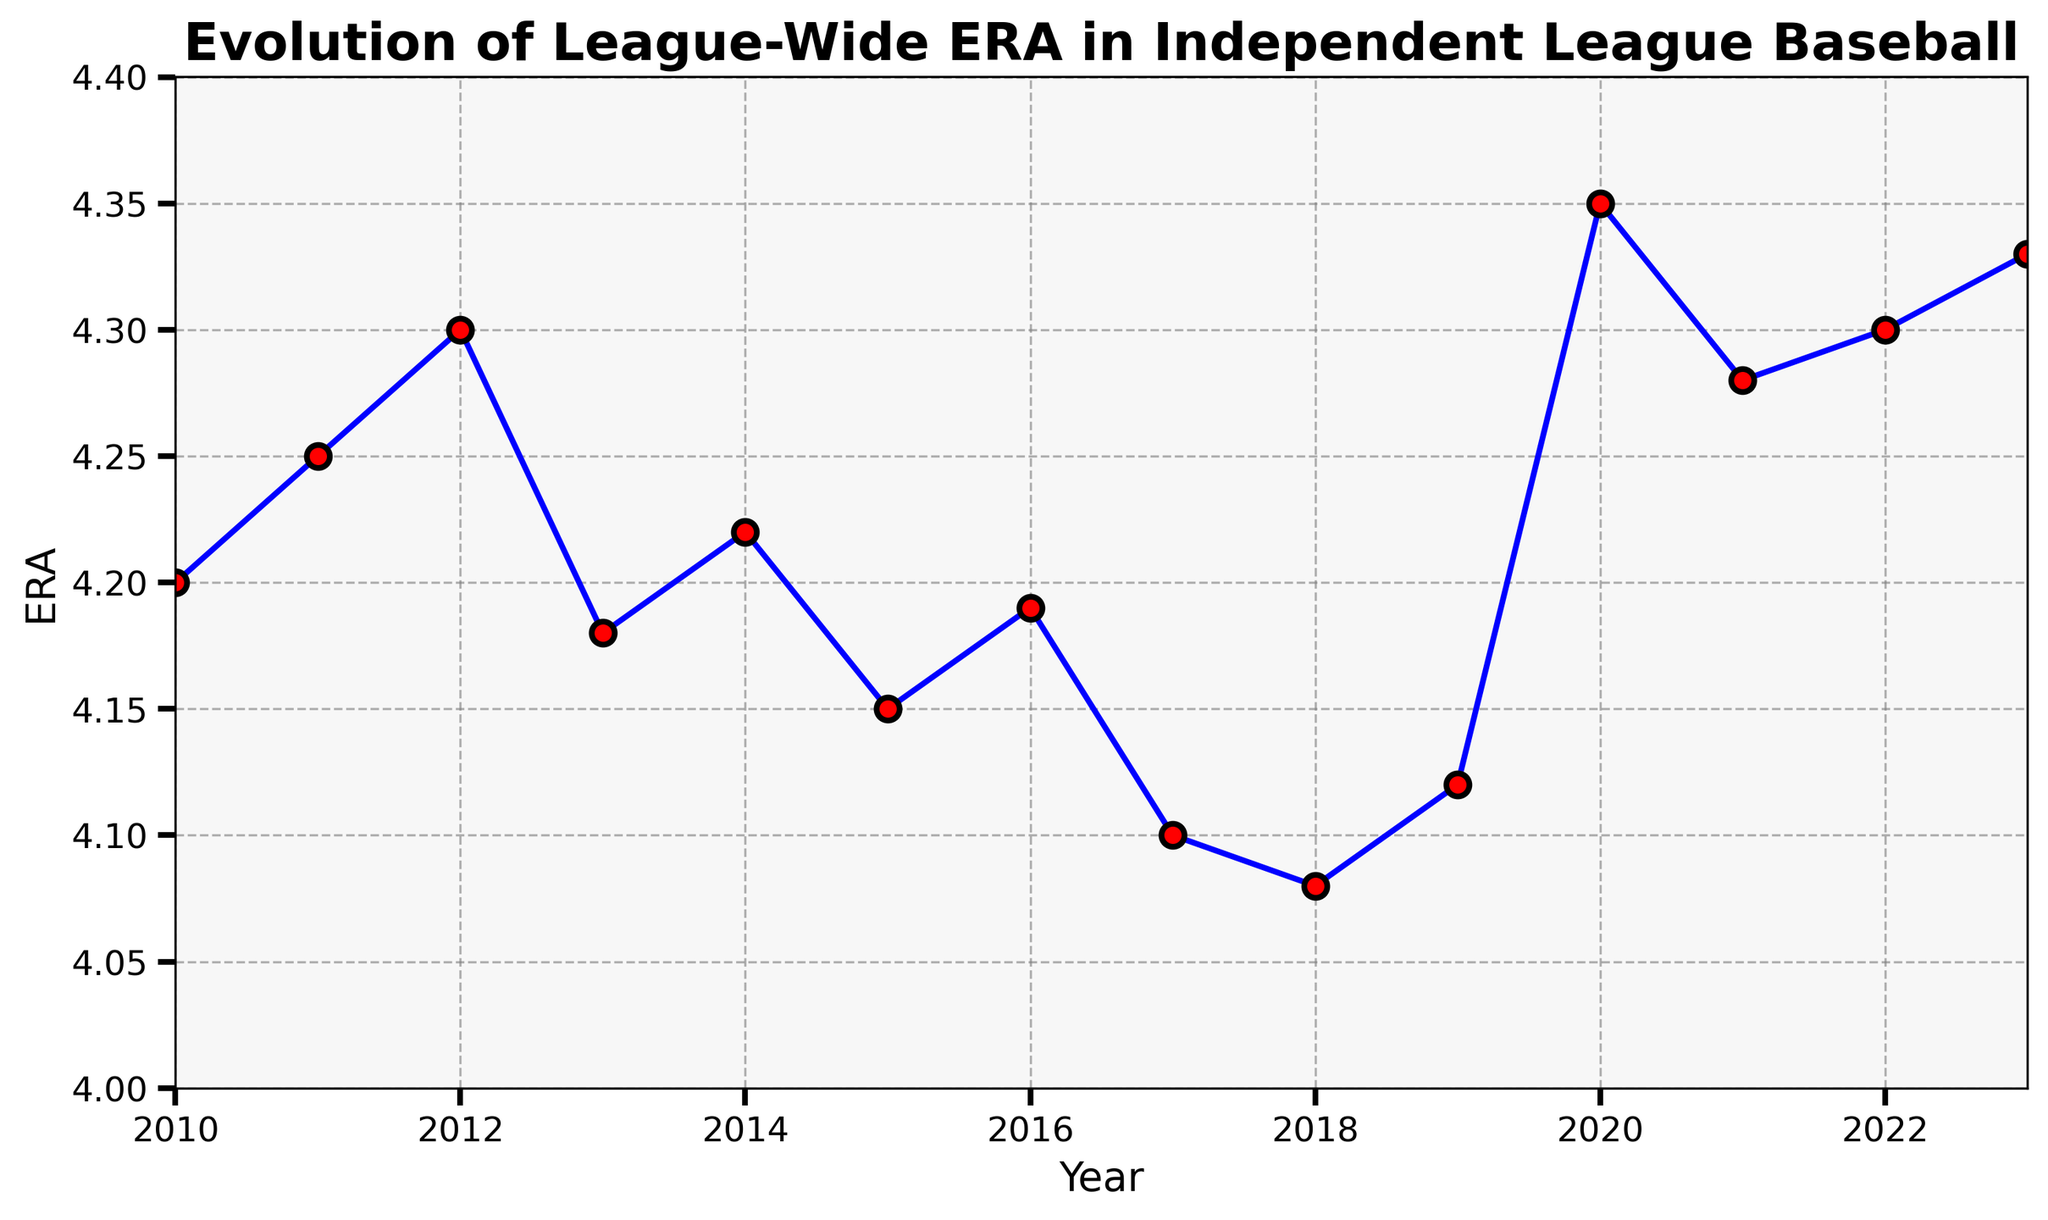Which year had the highest ERA? By examining the line chart, we see that the highest point on the y-axis (ERA) is in 2020.
Answer: 2020 What is the difference in ERA between the years 2012 and 2018? Find the ERA value for both years from the chart. The ERA for 2012 is 4.30 and for 2018 is 4.08. Subtract the ERA of 2018 from that of 2012: 4.30 - 4.08 = 0.22.
Answer: 0.22 Which year had the lowest ERA? The lowest point on the y-axis (ERA) can be seen in the chart and it is in 2018.
Answer: 2018 What is the average ERA from 2010 to 2015? First, list the ERA values for each year from 2010 to 2015: 4.20, 4.25, 4.30, 4.18, 4.22, 4.15. Calculate the sum: 4.20 + 4.25 + 4.30 + 4.18 + 4.22 + 4.15 = 25.30. Then divide by the number of years (6): 25.30 / 6 = 4.22.
Answer: 4.22 Is the ERA in 2022 greater than or less than the ERA in 2021? By looking at the chart, the ERA for 2022 and 2021 are 4.30 and 4.28 respectively. Since 4.30 > 4.28, the ERA in 2022 is greater than that in 2021.
Answer: Greater What is the biggest year-over-year increase in ERA? Examine the year-over-year changes in ERA. The largest increase occurs between 2019 and 2020 where the ERA jumps from 4.12 to 4.35. Calculate the difference: 4.35 - 4.12 = 0.23.
Answer: 0.23 During which period (year range) did the ERA see a consecutive decline? Observing the line chart, the ERA consecutively declines between 2015 and 2018: 2015 (4.15), 2016 (4.19), 2017 (4.10), and 2018 (4.08).
Answer: 2015-2018 What is the total increase in ERA from 2018 to 2023? Identify the ERA values for 2018 (4.08) and 2023 (4.33). Calculate the difference: 4.33 - 4.08 = 0.25.
Answer: 0.25 Between which two consecutive years did the ERA decrease the most? Look at the differences between consecutive years' ERAs. The steepest decline occurs between 2016 (4.19) and 2017 (4.10). Calculate the difference: 4.19 - 4.10 = 0.09.
Answer: 2016 and 2017 